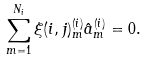Convert formula to latex. <formula><loc_0><loc_0><loc_500><loc_500>\sum _ { m = 1 } ^ { N _ { i } } \xi ( i , j ) ^ { ( i ) } _ { m } \hat { a } _ { m } ^ { ( i ) } = { 0 } .</formula> 